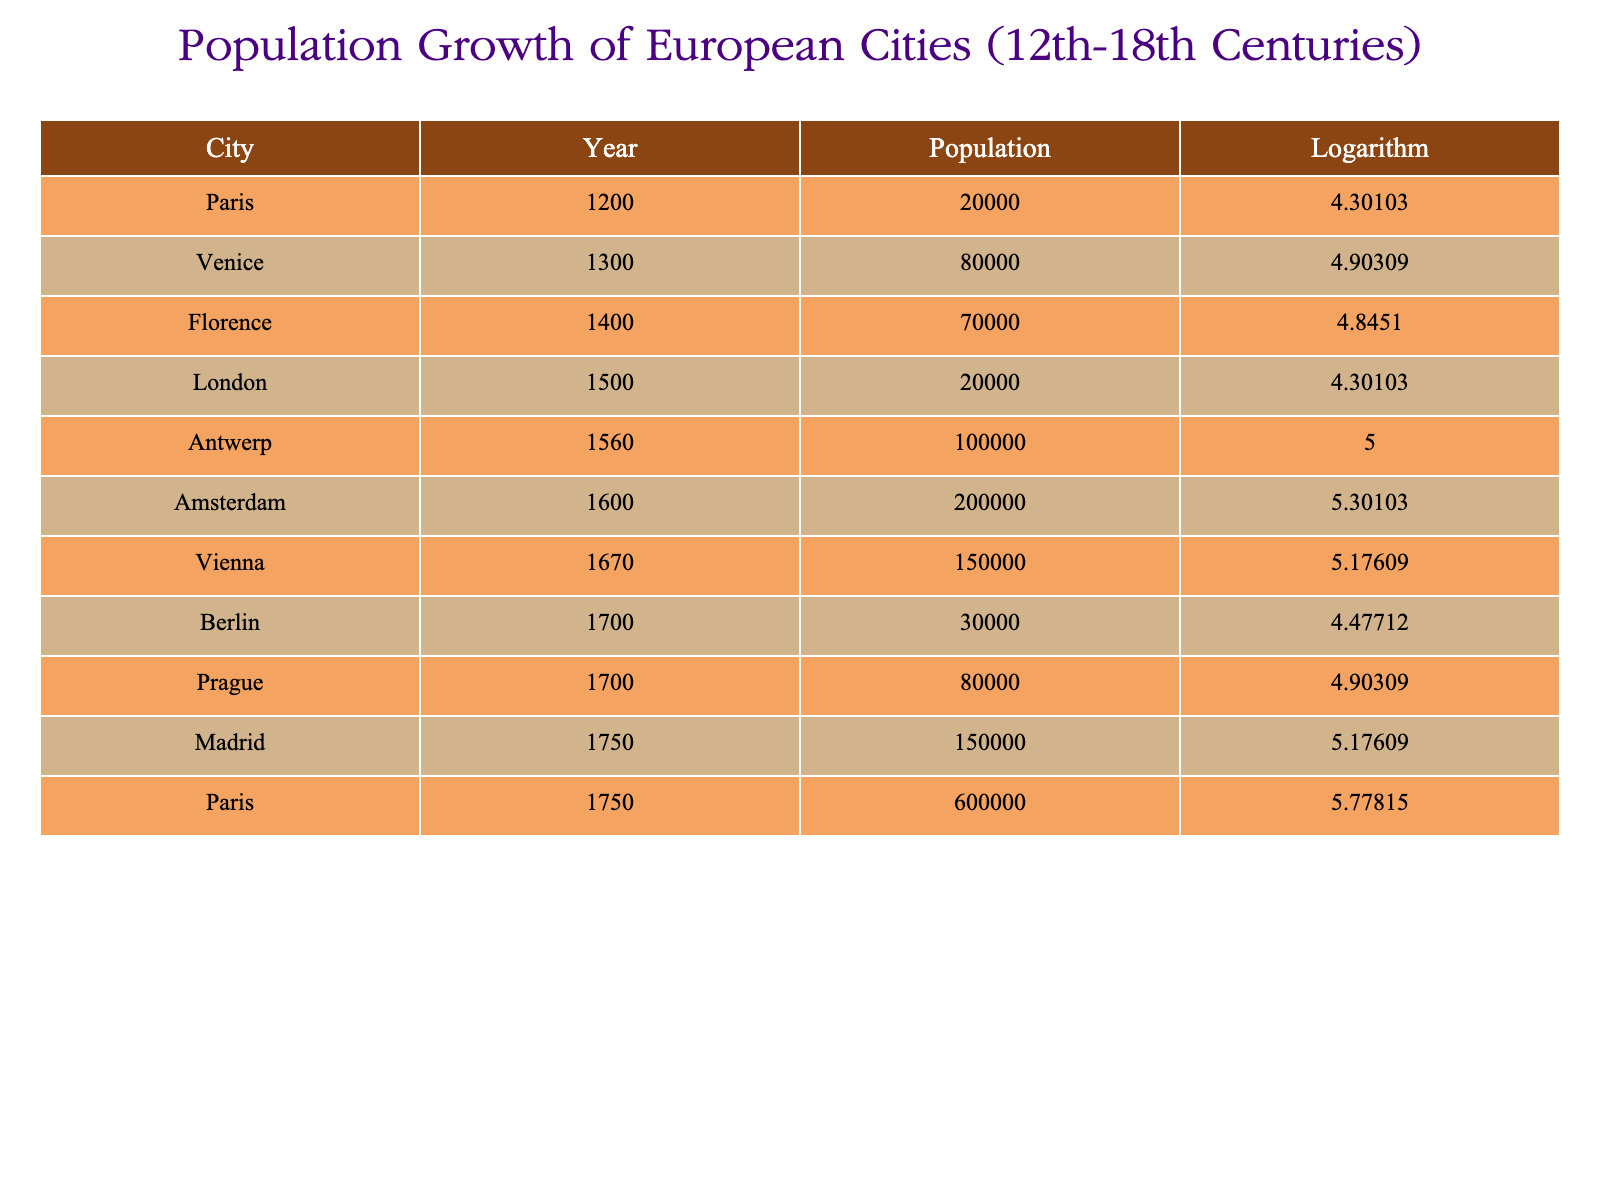What was the population of Paris in 1750? Referring directly to the table, the row for Paris in 1750 states that the population was 600,000.
Answer: 600,000 Which city had the highest population recorded in the table? By examining the population figures provided for each city, Antwerp in 1560 had the highest population recorded at 100,000.
Answer: 100,000 What is the difference in population between Amsterdam in 1600 and Berlin in 1700? The population of Amsterdam in 1600 was 200,000, and the population of Berlin in 1700 was 30,000. The difference is calculated as 200,000 - 30,000 = 170,000.
Answer: 170,000 Did any cities have a population of more than 500,000? By scanning the data, only Paris in 1750 had a population of 600,000, confirming that there was a city with a population exceeding 500,000.
Answer: Yes What was the average population of the cities listed for the year 1700? In 1700, the populations of the cities listed are Berlin (30,000) and Prague (80,000). To find the average, we sum these populations: 30,000 + 80,000 = 110,000, and divide by 2 (the number of cities), resulting in an average of 55,000.
Answer: 55,000 How much did the population of London change from 1500 to 1750? The population of London in 1500 was 20,000, and in 1750 it was not listed separately; only Paris is mentioned for that year. Hence, there's no population change to report for London.
Answer: N/A Which city saw a population increase from the 12th to the 18th century, and what was that increase? When comparing the populations, Paris increased from 20,000 in 1200 to 600,000 in 1750. The increase can be calculated as 600,000 - 20,000 = 580,000.
Answer: 580,000 Which two cities had the same population in the year 1700? According to the table, both Berlin and Prague were listed for the year 1700, but they had different populations of 30,000 and 80,000, respectively, indicating they were not the same.
Answer: No What trend can we observe regarding the populations in the 16th century compared to the 18th century? Specifically, if we compare Antwerp in the 16th century (100,000) with Madrid in the 18th century (150,000) indicates a general trend of increasing urban populations over time.
Answer: Increasing populations 